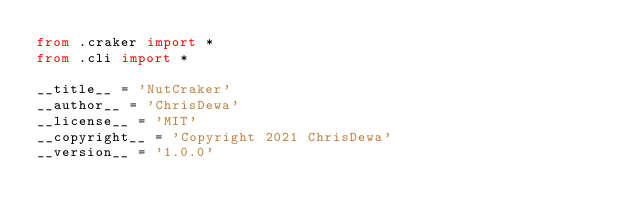<code> <loc_0><loc_0><loc_500><loc_500><_Python_>from .craker import *
from .cli import *

__title__ = 'NutCraker'
__author__ = 'ChrisDewa'
__license__ = 'MIT'
__copyright__ = 'Copyright 2021 ChrisDewa'
__version__ = '1.0.0'
</code> 